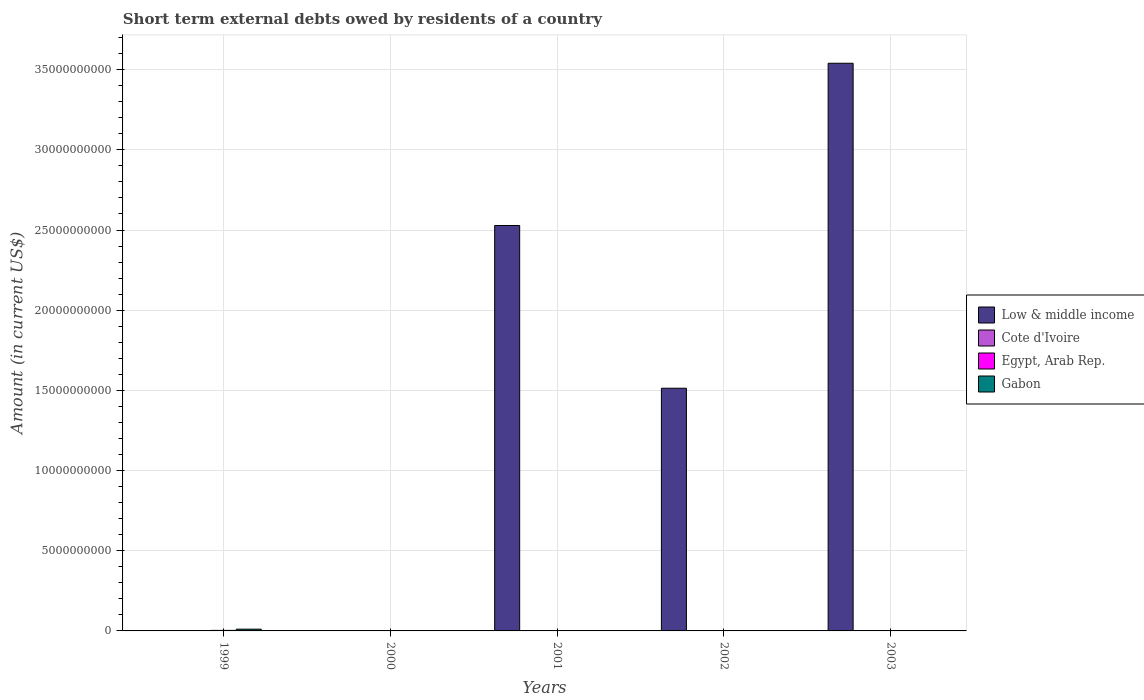Are the number of bars per tick equal to the number of legend labels?
Your response must be concise. No. Are the number of bars on each tick of the X-axis equal?
Your answer should be compact. No. What is the label of the 2nd group of bars from the left?
Provide a short and direct response. 2000. In how many cases, is the number of bars for a given year not equal to the number of legend labels?
Offer a terse response. 5. What is the amount of short-term external debts owed by residents in Egypt, Arab Rep. in 2001?
Offer a terse response. 0. Across all years, what is the maximum amount of short-term external debts owed by residents in Egypt, Arab Rep.?
Your response must be concise. 3.37e+07. In which year was the amount of short-term external debts owed by residents in Gabon maximum?
Offer a very short reply. 1999. What is the total amount of short-term external debts owed by residents in Gabon in the graph?
Offer a terse response. 1.11e+08. What is the difference between the amount of short-term external debts owed by residents in Gabon in 1999 and that in 2001?
Your answer should be very brief. 1.07e+08. What is the difference between the amount of short-term external debts owed by residents in Gabon in 2001 and the amount of short-term external debts owed by residents in Low & middle income in 1999?
Your response must be concise. 2.00e+06. What is the average amount of short-term external debts owed by residents in Low & middle income per year?
Ensure brevity in your answer.  1.52e+1. In how many years, is the amount of short-term external debts owed by residents in Low & middle income greater than 22000000000 US$?
Make the answer very short. 2. What is the difference between the highest and the second highest amount of short-term external debts owed by residents in Low & middle income?
Give a very brief answer. 1.01e+1. What is the difference between the highest and the lowest amount of short-term external debts owed by residents in Egypt, Arab Rep.?
Give a very brief answer. 3.37e+07. Is it the case that in every year, the sum of the amount of short-term external debts owed by residents in Cote d'Ivoire and amount of short-term external debts owed by residents in Egypt, Arab Rep. is greater than the sum of amount of short-term external debts owed by residents in Low & middle income and amount of short-term external debts owed by residents in Gabon?
Keep it short and to the point. No. Is it the case that in every year, the sum of the amount of short-term external debts owed by residents in Low & middle income and amount of short-term external debts owed by residents in Egypt, Arab Rep. is greater than the amount of short-term external debts owed by residents in Gabon?
Offer a terse response. No. How many bars are there?
Keep it short and to the point. 6. Are all the bars in the graph horizontal?
Ensure brevity in your answer.  No. How many years are there in the graph?
Give a very brief answer. 5. Are the values on the major ticks of Y-axis written in scientific E-notation?
Your response must be concise. No. Where does the legend appear in the graph?
Your answer should be compact. Center right. What is the title of the graph?
Provide a short and direct response. Short term external debts owed by residents of a country. Does "Guinea" appear as one of the legend labels in the graph?
Offer a very short reply. No. What is the label or title of the X-axis?
Offer a very short reply. Years. What is the Amount (in current US$) of Cote d'Ivoire in 1999?
Ensure brevity in your answer.  0. What is the Amount (in current US$) in Egypt, Arab Rep. in 1999?
Offer a terse response. 3.37e+07. What is the Amount (in current US$) in Gabon in 1999?
Keep it short and to the point. 1.09e+08. What is the Amount (in current US$) of Low & middle income in 2001?
Your answer should be compact. 2.53e+1. What is the Amount (in current US$) in Gabon in 2001?
Your answer should be very brief. 2.00e+06. What is the Amount (in current US$) in Low & middle income in 2002?
Your answer should be very brief. 1.51e+1. What is the Amount (in current US$) of Egypt, Arab Rep. in 2002?
Provide a short and direct response. 0. What is the Amount (in current US$) of Low & middle income in 2003?
Your answer should be very brief. 3.54e+1. What is the Amount (in current US$) in Cote d'Ivoire in 2003?
Make the answer very short. 0. What is the Amount (in current US$) in Egypt, Arab Rep. in 2003?
Offer a very short reply. 0. What is the Amount (in current US$) in Gabon in 2003?
Ensure brevity in your answer.  0. Across all years, what is the maximum Amount (in current US$) in Low & middle income?
Your response must be concise. 3.54e+1. Across all years, what is the maximum Amount (in current US$) in Egypt, Arab Rep.?
Your response must be concise. 3.37e+07. Across all years, what is the maximum Amount (in current US$) of Gabon?
Provide a succinct answer. 1.09e+08. Across all years, what is the minimum Amount (in current US$) in Egypt, Arab Rep.?
Offer a terse response. 0. What is the total Amount (in current US$) in Low & middle income in the graph?
Offer a terse response. 7.58e+1. What is the total Amount (in current US$) of Egypt, Arab Rep. in the graph?
Keep it short and to the point. 3.37e+07. What is the total Amount (in current US$) of Gabon in the graph?
Offer a terse response. 1.11e+08. What is the difference between the Amount (in current US$) in Gabon in 1999 and that in 2001?
Your response must be concise. 1.07e+08. What is the difference between the Amount (in current US$) of Low & middle income in 2001 and that in 2002?
Your answer should be very brief. 1.01e+1. What is the difference between the Amount (in current US$) of Low & middle income in 2001 and that in 2003?
Ensure brevity in your answer.  -1.01e+1. What is the difference between the Amount (in current US$) in Low & middle income in 2002 and that in 2003?
Your answer should be compact. -2.03e+1. What is the difference between the Amount (in current US$) in Egypt, Arab Rep. in 1999 and the Amount (in current US$) in Gabon in 2001?
Provide a short and direct response. 3.17e+07. What is the average Amount (in current US$) in Low & middle income per year?
Your answer should be very brief. 1.52e+1. What is the average Amount (in current US$) in Egypt, Arab Rep. per year?
Ensure brevity in your answer.  6.74e+06. What is the average Amount (in current US$) in Gabon per year?
Your answer should be very brief. 2.22e+07. In the year 1999, what is the difference between the Amount (in current US$) in Egypt, Arab Rep. and Amount (in current US$) in Gabon?
Give a very brief answer. -7.54e+07. In the year 2001, what is the difference between the Amount (in current US$) of Low & middle income and Amount (in current US$) of Gabon?
Provide a short and direct response. 2.53e+1. What is the ratio of the Amount (in current US$) of Gabon in 1999 to that in 2001?
Give a very brief answer. 54.55. What is the ratio of the Amount (in current US$) of Low & middle income in 2001 to that in 2002?
Keep it short and to the point. 1.67. What is the ratio of the Amount (in current US$) of Low & middle income in 2001 to that in 2003?
Your answer should be compact. 0.71. What is the ratio of the Amount (in current US$) of Low & middle income in 2002 to that in 2003?
Your response must be concise. 0.43. What is the difference between the highest and the second highest Amount (in current US$) of Low & middle income?
Provide a short and direct response. 1.01e+1. What is the difference between the highest and the lowest Amount (in current US$) of Low & middle income?
Offer a very short reply. 3.54e+1. What is the difference between the highest and the lowest Amount (in current US$) in Egypt, Arab Rep.?
Ensure brevity in your answer.  3.37e+07. What is the difference between the highest and the lowest Amount (in current US$) of Gabon?
Provide a short and direct response. 1.09e+08. 